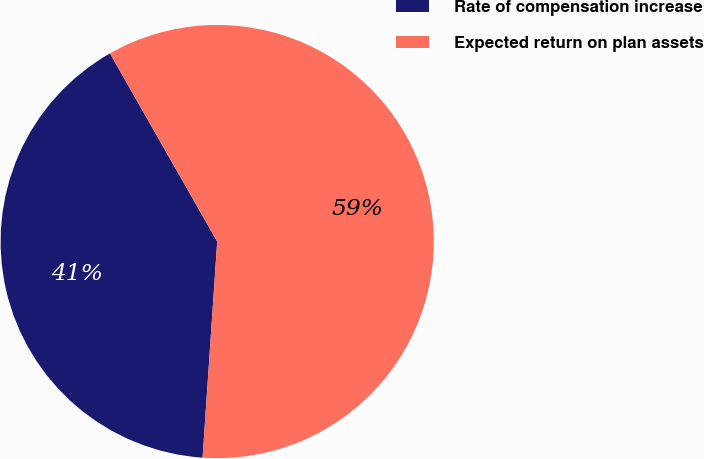Convert chart to OTSL. <chart><loc_0><loc_0><loc_500><loc_500><pie_chart><fcel>Rate of compensation increase<fcel>Expected return on plan assets<nl><fcel>40.68%<fcel>59.32%<nl></chart> 